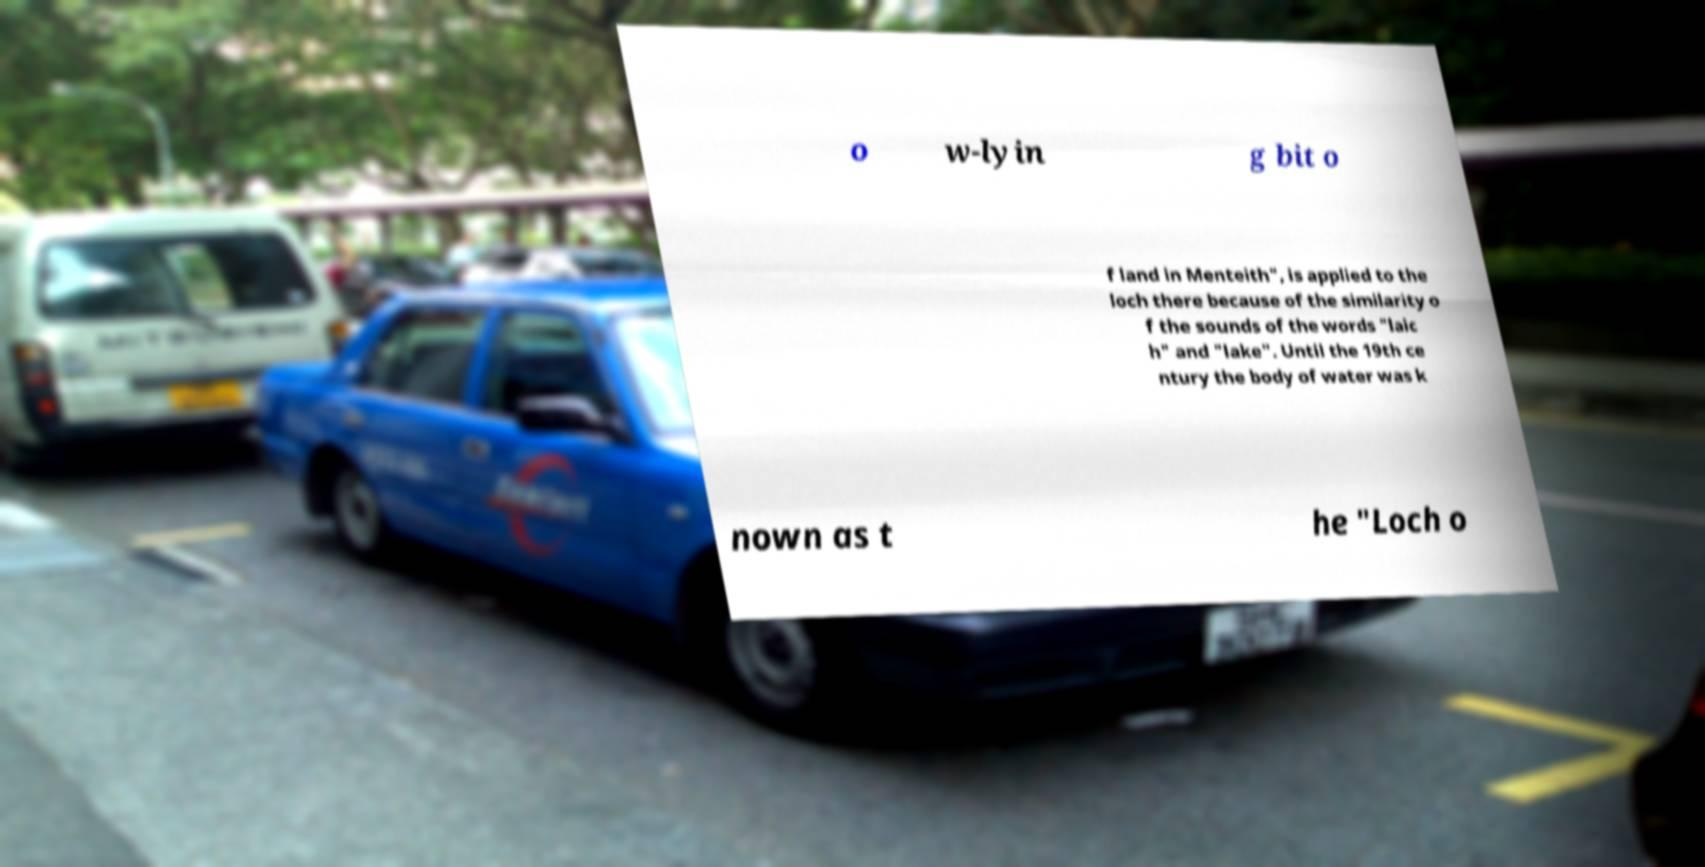There's text embedded in this image that I need extracted. Can you transcribe it verbatim? o w-lyin g bit o f land in Menteith", is applied to the loch there because of the similarity o f the sounds of the words "laic h" and "lake". Until the 19th ce ntury the body of water was k nown as t he "Loch o 